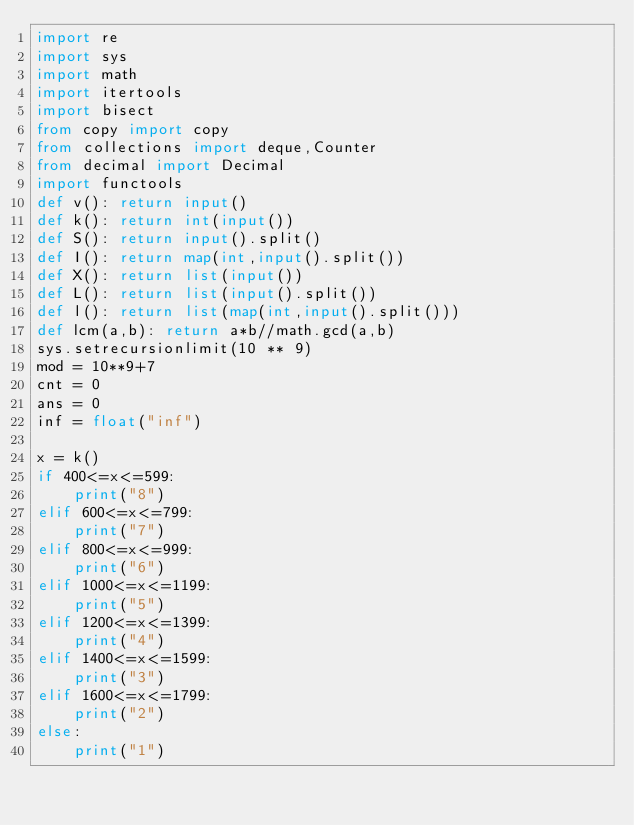Convert code to text. <code><loc_0><loc_0><loc_500><loc_500><_Python_>import re
import sys
import math
import itertools
import bisect
from copy import copy
from collections import deque,Counter
from decimal import Decimal
import functools
def v(): return input()
def k(): return int(input())
def S(): return input().split()
def I(): return map(int,input().split())
def X(): return list(input())
def L(): return list(input().split())
def l(): return list(map(int,input().split()))
def lcm(a,b): return a*b//math.gcd(a,b)
sys.setrecursionlimit(10 ** 9)
mod = 10**9+7
cnt = 0
ans = 0
inf = float("inf")

x = k()
if 400<=x<=599:
    print("8")
elif 600<=x<=799:
    print("7")
elif 800<=x<=999:
    print("6")
elif 1000<=x<=1199:
    print("5")
elif 1200<=x<=1399:
    print("4")
elif 1400<=x<=1599:
    print("3")
elif 1600<=x<=1799:
    print("2")
else:
    print("1")
</code> 